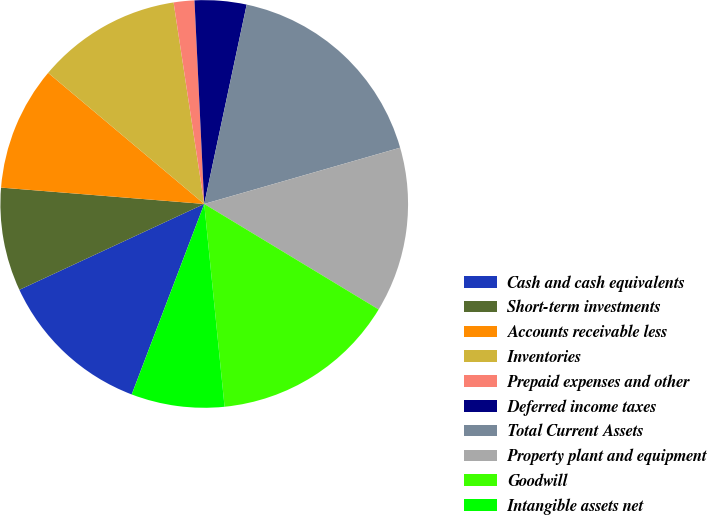Convert chart. <chart><loc_0><loc_0><loc_500><loc_500><pie_chart><fcel>Cash and cash equivalents<fcel>Short-term investments<fcel>Accounts receivable less<fcel>Inventories<fcel>Prepaid expenses and other<fcel>Deferred income taxes<fcel>Total Current Assets<fcel>Property plant and equipment<fcel>Goodwill<fcel>Intangible assets net<nl><fcel>12.29%<fcel>8.2%<fcel>9.84%<fcel>11.48%<fcel>1.64%<fcel>4.1%<fcel>17.21%<fcel>13.11%<fcel>14.75%<fcel>7.38%<nl></chart> 